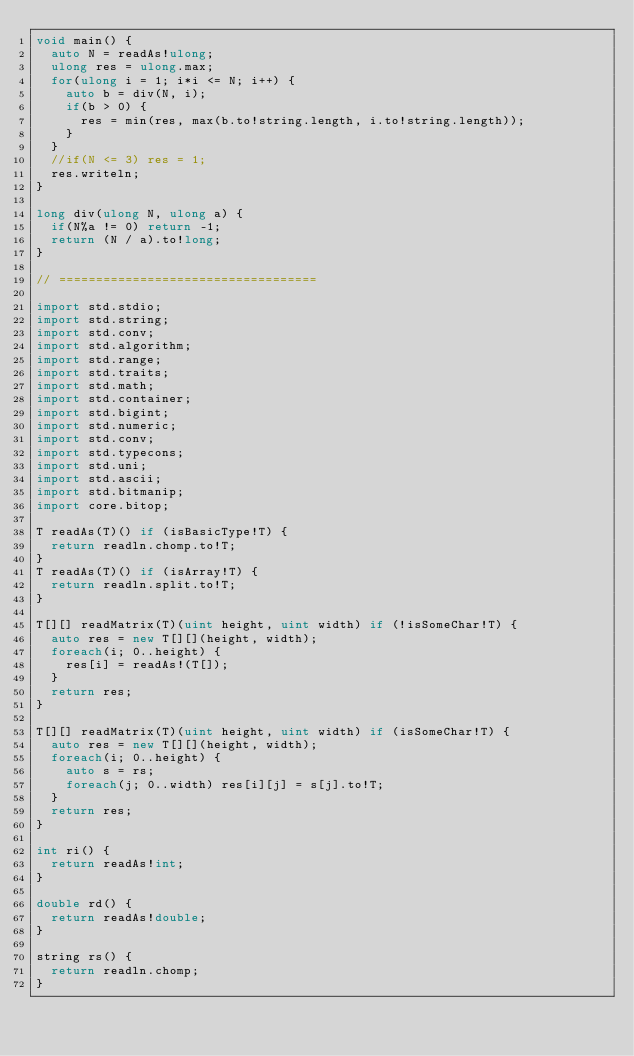Convert code to text. <code><loc_0><loc_0><loc_500><loc_500><_D_>void main() {
	auto N = readAs!ulong;
	ulong res = ulong.max;
	for(ulong i = 1; i*i <= N; i++) {
		auto b = div(N, i);
		if(b > 0) {
			res = min(res, max(b.to!string.length, i.to!string.length));
		}
	}
	//if(N <= 3) res = 1;
	res.writeln;
}

long div(ulong N, ulong a) {
	if(N%a != 0) return -1;
	return (N / a).to!long;
}

// ===================================

import std.stdio;
import std.string;
import std.conv;
import std.algorithm;
import std.range;
import std.traits;
import std.math;
import std.container;
import std.bigint;
import std.numeric;
import std.conv;
import std.typecons;
import std.uni;
import std.ascii;
import std.bitmanip;
import core.bitop;

T readAs(T)() if (isBasicType!T) {
	return readln.chomp.to!T;
}
T readAs(T)() if (isArray!T) {
	return readln.split.to!T;
}

T[][] readMatrix(T)(uint height, uint width) if (!isSomeChar!T) {
	auto res = new T[][](height, width);
	foreach(i; 0..height) {
		res[i] = readAs!(T[]);
	}
	return res;
}

T[][] readMatrix(T)(uint height, uint width) if (isSomeChar!T) {
	auto res = new T[][](height, width);
	foreach(i; 0..height) {
		auto s = rs;
		foreach(j; 0..width) res[i][j] = s[j].to!T;
	}
	return res;
}

int ri() {
	return readAs!int;
}

double rd() {
	return readAs!double;
}

string rs() {
	return readln.chomp;
}</code> 